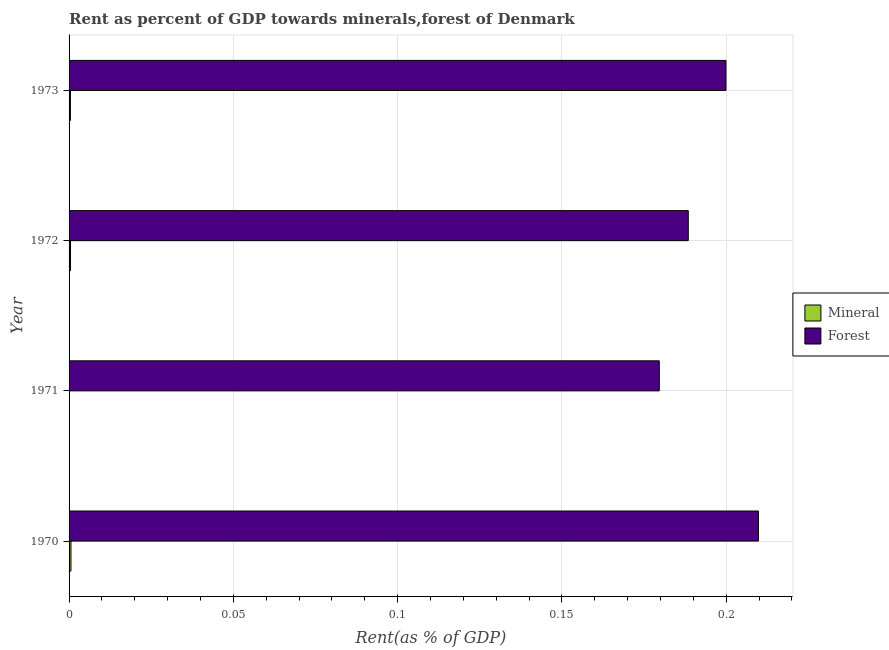How many different coloured bars are there?
Your answer should be compact. 2. How many groups of bars are there?
Ensure brevity in your answer.  4. Are the number of bars on each tick of the Y-axis equal?
Keep it short and to the point. Yes. How many bars are there on the 2nd tick from the top?
Keep it short and to the point. 2. How many bars are there on the 2nd tick from the bottom?
Your answer should be very brief. 2. What is the label of the 4th group of bars from the top?
Provide a succinct answer. 1970. In how many cases, is the number of bars for a given year not equal to the number of legend labels?
Offer a very short reply. 0. What is the forest rent in 1972?
Your answer should be very brief. 0.19. Across all years, what is the maximum forest rent?
Provide a succinct answer. 0.21. Across all years, what is the minimum forest rent?
Offer a very short reply. 0.18. In which year was the forest rent minimum?
Ensure brevity in your answer.  1971. What is the total forest rent in the graph?
Your answer should be very brief. 0.78. What is the difference between the mineral rent in 1971 and that in 1972?
Make the answer very short. -0. What is the difference between the forest rent in 1971 and the mineral rent in 1973?
Give a very brief answer. 0.18. In the year 1971, what is the difference between the mineral rent and forest rent?
Ensure brevity in your answer.  -0.18. In how many years, is the mineral rent greater than 0.02 %?
Keep it short and to the point. 0. What is the ratio of the forest rent in 1971 to that in 1973?
Offer a terse response. 0.9. What is the difference between the highest and the lowest mineral rent?
Provide a succinct answer. 0. In how many years, is the mineral rent greater than the average mineral rent taken over all years?
Make the answer very short. 3. Is the sum of the mineral rent in 1972 and 1973 greater than the maximum forest rent across all years?
Make the answer very short. No. What does the 1st bar from the top in 1972 represents?
Make the answer very short. Forest. What does the 2nd bar from the bottom in 1973 represents?
Provide a short and direct response. Forest. How many bars are there?
Provide a short and direct response. 8. Are all the bars in the graph horizontal?
Keep it short and to the point. Yes. Does the graph contain any zero values?
Give a very brief answer. No. How are the legend labels stacked?
Provide a succinct answer. Vertical. What is the title of the graph?
Provide a short and direct response. Rent as percent of GDP towards minerals,forest of Denmark. Does "Quality of trade" appear as one of the legend labels in the graph?
Make the answer very short. No. What is the label or title of the X-axis?
Offer a terse response. Rent(as % of GDP). What is the Rent(as % of GDP) in Mineral in 1970?
Your answer should be compact. 0. What is the Rent(as % of GDP) of Forest in 1970?
Your answer should be compact. 0.21. What is the Rent(as % of GDP) in Mineral in 1971?
Provide a short and direct response. 8.546909681479509e-5. What is the Rent(as % of GDP) of Forest in 1971?
Ensure brevity in your answer.  0.18. What is the Rent(as % of GDP) of Mineral in 1972?
Give a very brief answer. 0. What is the Rent(as % of GDP) in Forest in 1972?
Your answer should be compact. 0.19. What is the Rent(as % of GDP) of Mineral in 1973?
Provide a short and direct response. 0. What is the Rent(as % of GDP) in Forest in 1973?
Provide a short and direct response. 0.2. Across all years, what is the maximum Rent(as % of GDP) in Mineral?
Offer a terse response. 0. Across all years, what is the maximum Rent(as % of GDP) in Forest?
Offer a very short reply. 0.21. Across all years, what is the minimum Rent(as % of GDP) in Mineral?
Your answer should be very brief. 8.546909681479509e-5. Across all years, what is the minimum Rent(as % of GDP) in Forest?
Your answer should be compact. 0.18. What is the total Rent(as % of GDP) in Mineral in the graph?
Your answer should be very brief. 0. What is the total Rent(as % of GDP) in Forest in the graph?
Keep it short and to the point. 0.78. What is the difference between the Rent(as % of GDP) in Mineral in 1970 and that in 1971?
Provide a succinct answer. 0. What is the difference between the Rent(as % of GDP) in Forest in 1970 and that in 1971?
Your answer should be compact. 0.03. What is the difference between the Rent(as % of GDP) in Forest in 1970 and that in 1972?
Provide a succinct answer. 0.02. What is the difference between the Rent(as % of GDP) in Forest in 1970 and that in 1973?
Your response must be concise. 0.01. What is the difference between the Rent(as % of GDP) of Mineral in 1971 and that in 1972?
Make the answer very short. -0. What is the difference between the Rent(as % of GDP) of Forest in 1971 and that in 1972?
Provide a short and direct response. -0.01. What is the difference between the Rent(as % of GDP) in Mineral in 1971 and that in 1973?
Make the answer very short. -0. What is the difference between the Rent(as % of GDP) of Forest in 1971 and that in 1973?
Your answer should be compact. -0.02. What is the difference between the Rent(as % of GDP) in Mineral in 1972 and that in 1973?
Offer a very short reply. 0. What is the difference between the Rent(as % of GDP) of Forest in 1972 and that in 1973?
Provide a succinct answer. -0.01. What is the difference between the Rent(as % of GDP) in Mineral in 1970 and the Rent(as % of GDP) in Forest in 1971?
Offer a terse response. -0.18. What is the difference between the Rent(as % of GDP) in Mineral in 1970 and the Rent(as % of GDP) in Forest in 1972?
Offer a terse response. -0.19. What is the difference between the Rent(as % of GDP) in Mineral in 1970 and the Rent(as % of GDP) in Forest in 1973?
Your answer should be compact. -0.2. What is the difference between the Rent(as % of GDP) of Mineral in 1971 and the Rent(as % of GDP) of Forest in 1972?
Make the answer very short. -0.19. What is the difference between the Rent(as % of GDP) of Mineral in 1971 and the Rent(as % of GDP) of Forest in 1973?
Make the answer very short. -0.2. What is the difference between the Rent(as % of GDP) in Mineral in 1972 and the Rent(as % of GDP) in Forest in 1973?
Your answer should be very brief. -0.2. What is the average Rent(as % of GDP) of Forest per year?
Provide a short and direct response. 0.19. In the year 1970, what is the difference between the Rent(as % of GDP) of Mineral and Rent(as % of GDP) of Forest?
Offer a very short reply. -0.21. In the year 1971, what is the difference between the Rent(as % of GDP) of Mineral and Rent(as % of GDP) of Forest?
Provide a short and direct response. -0.18. In the year 1972, what is the difference between the Rent(as % of GDP) in Mineral and Rent(as % of GDP) in Forest?
Keep it short and to the point. -0.19. In the year 1973, what is the difference between the Rent(as % of GDP) in Mineral and Rent(as % of GDP) in Forest?
Make the answer very short. -0.2. What is the ratio of the Rent(as % of GDP) in Mineral in 1970 to that in 1971?
Your answer should be very brief. 6.71. What is the ratio of the Rent(as % of GDP) of Forest in 1970 to that in 1971?
Ensure brevity in your answer.  1.17. What is the ratio of the Rent(as % of GDP) in Mineral in 1970 to that in 1972?
Make the answer very short. 1.3. What is the ratio of the Rent(as % of GDP) in Forest in 1970 to that in 1972?
Make the answer very short. 1.11. What is the ratio of the Rent(as % of GDP) in Mineral in 1970 to that in 1973?
Offer a terse response. 1.38. What is the ratio of the Rent(as % of GDP) of Forest in 1970 to that in 1973?
Ensure brevity in your answer.  1.05. What is the ratio of the Rent(as % of GDP) in Mineral in 1971 to that in 1972?
Your answer should be very brief. 0.19. What is the ratio of the Rent(as % of GDP) of Forest in 1971 to that in 1972?
Give a very brief answer. 0.95. What is the ratio of the Rent(as % of GDP) in Mineral in 1971 to that in 1973?
Your answer should be very brief. 0.21. What is the ratio of the Rent(as % of GDP) of Forest in 1971 to that in 1973?
Offer a very short reply. 0.9. What is the ratio of the Rent(as % of GDP) in Mineral in 1972 to that in 1973?
Offer a terse response. 1.06. What is the ratio of the Rent(as % of GDP) in Forest in 1972 to that in 1973?
Your answer should be compact. 0.94. What is the difference between the highest and the second highest Rent(as % of GDP) of Forest?
Make the answer very short. 0.01. What is the difference between the highest and the lowest Rent(as % of GDP) of Forest?
Ensure brevity in your answer.  0.03. 